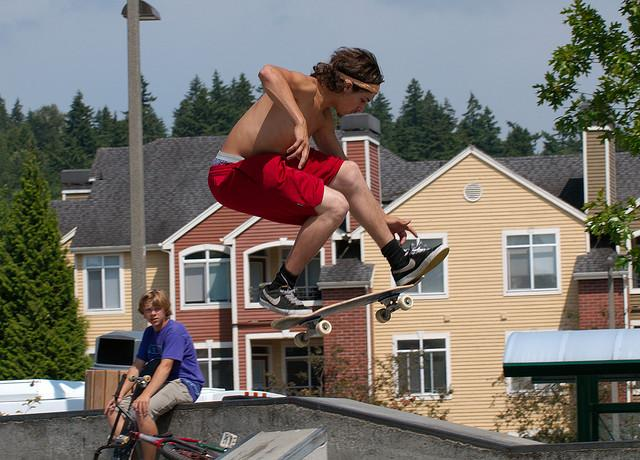What muscle do skater jumps Work? Please explain your reasoning. rump. A skateboarder is doing an arial trick on a skateboard. 